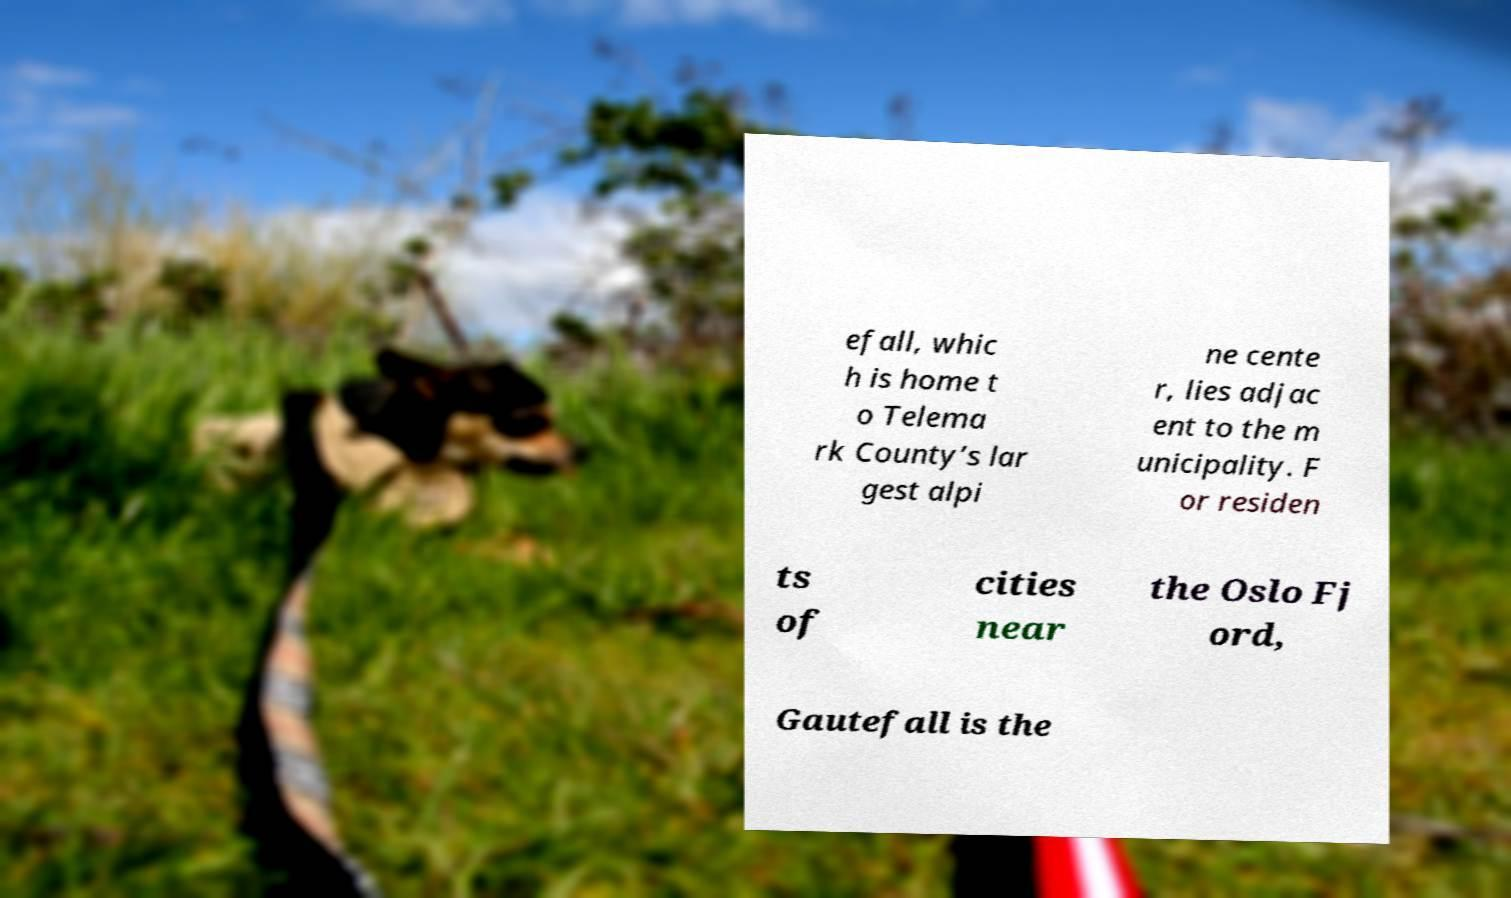Can you read and provide the text displayed in the image?This photo seems to have some interesting text. Can you extract and type it out for me? efall, whic h is home t o Telema rk County’s lar gest alpi ne cente r, lies adjac ent to the m unicipality. F or residen ts of cities near the Oslo Fj ord, Gautefall is the 